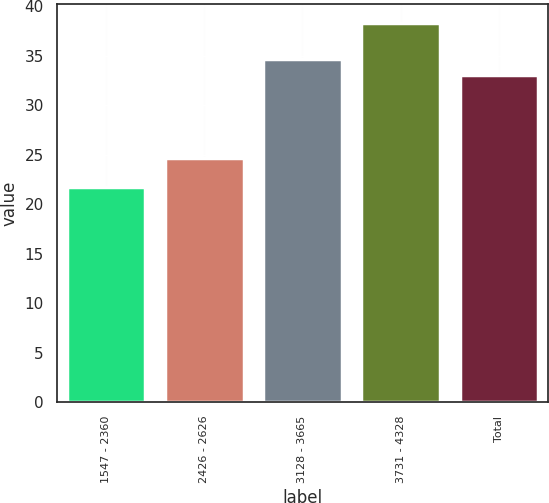<chart> <loc_0><loc_0><loc_500><loc_500><bar_chart><fcel>1547 - 2360<fcel>2426 - 2626<fcel>3128 - 3665<fcel>3731 - 4328<fcel>Total<nl><fcel>21.79<fcel>24.72<fcel>34.72<fcel>38.34<fcel>33.06<nl></chart> 